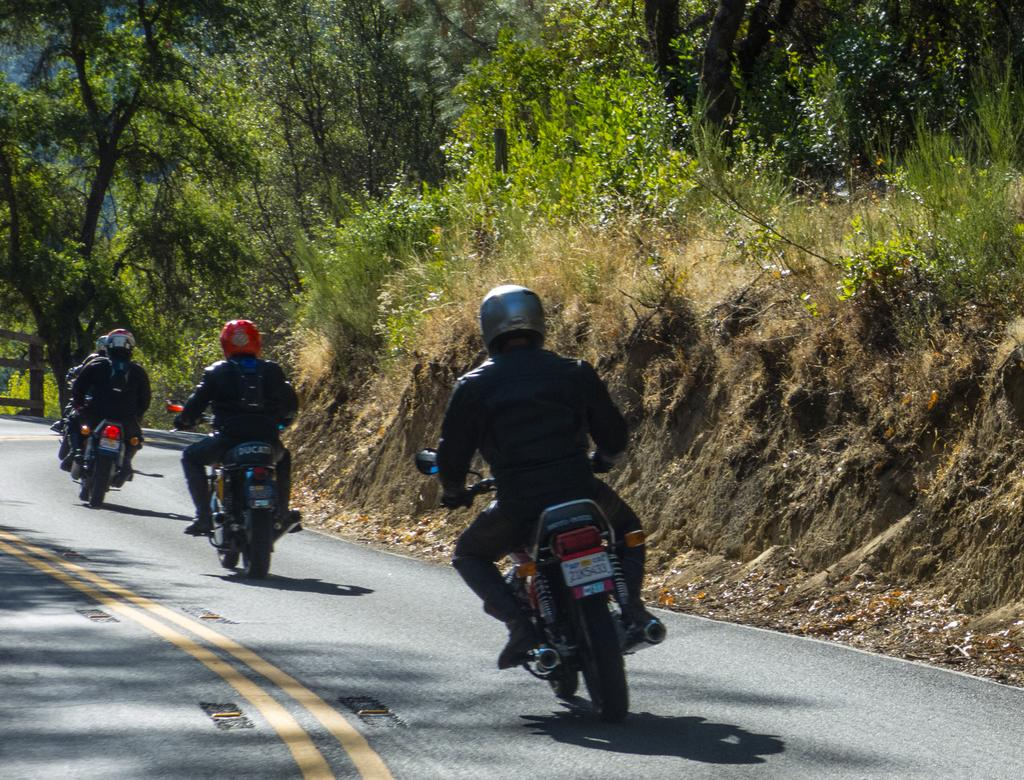What is happening on the road in the image? There are vehicles on the road in the image, and people are sitting on them. What are the people wearing while riding the vehicles? The people are wearing helmets. What can be seen in the background of the image? There are trees and grass visible in the background of the image. What type of cushion is being used to support the ice on the vehicles in the image? There is no ice or cushion present in the image; it features vehicles with people wearing helmets. What organization is responsible for the ice on the vehicles in the image? There is no ice or organization mentioned in the image; it only shows vehicles with people wearing helmets. 